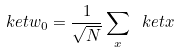<formula> <loc_0><loc_0><loc_500><loc_500>\ k e t { w _ { 0 } } = \frac { 1 } { \sqrt { N } } \sum _ { x } \ k e t { x }</formula> 